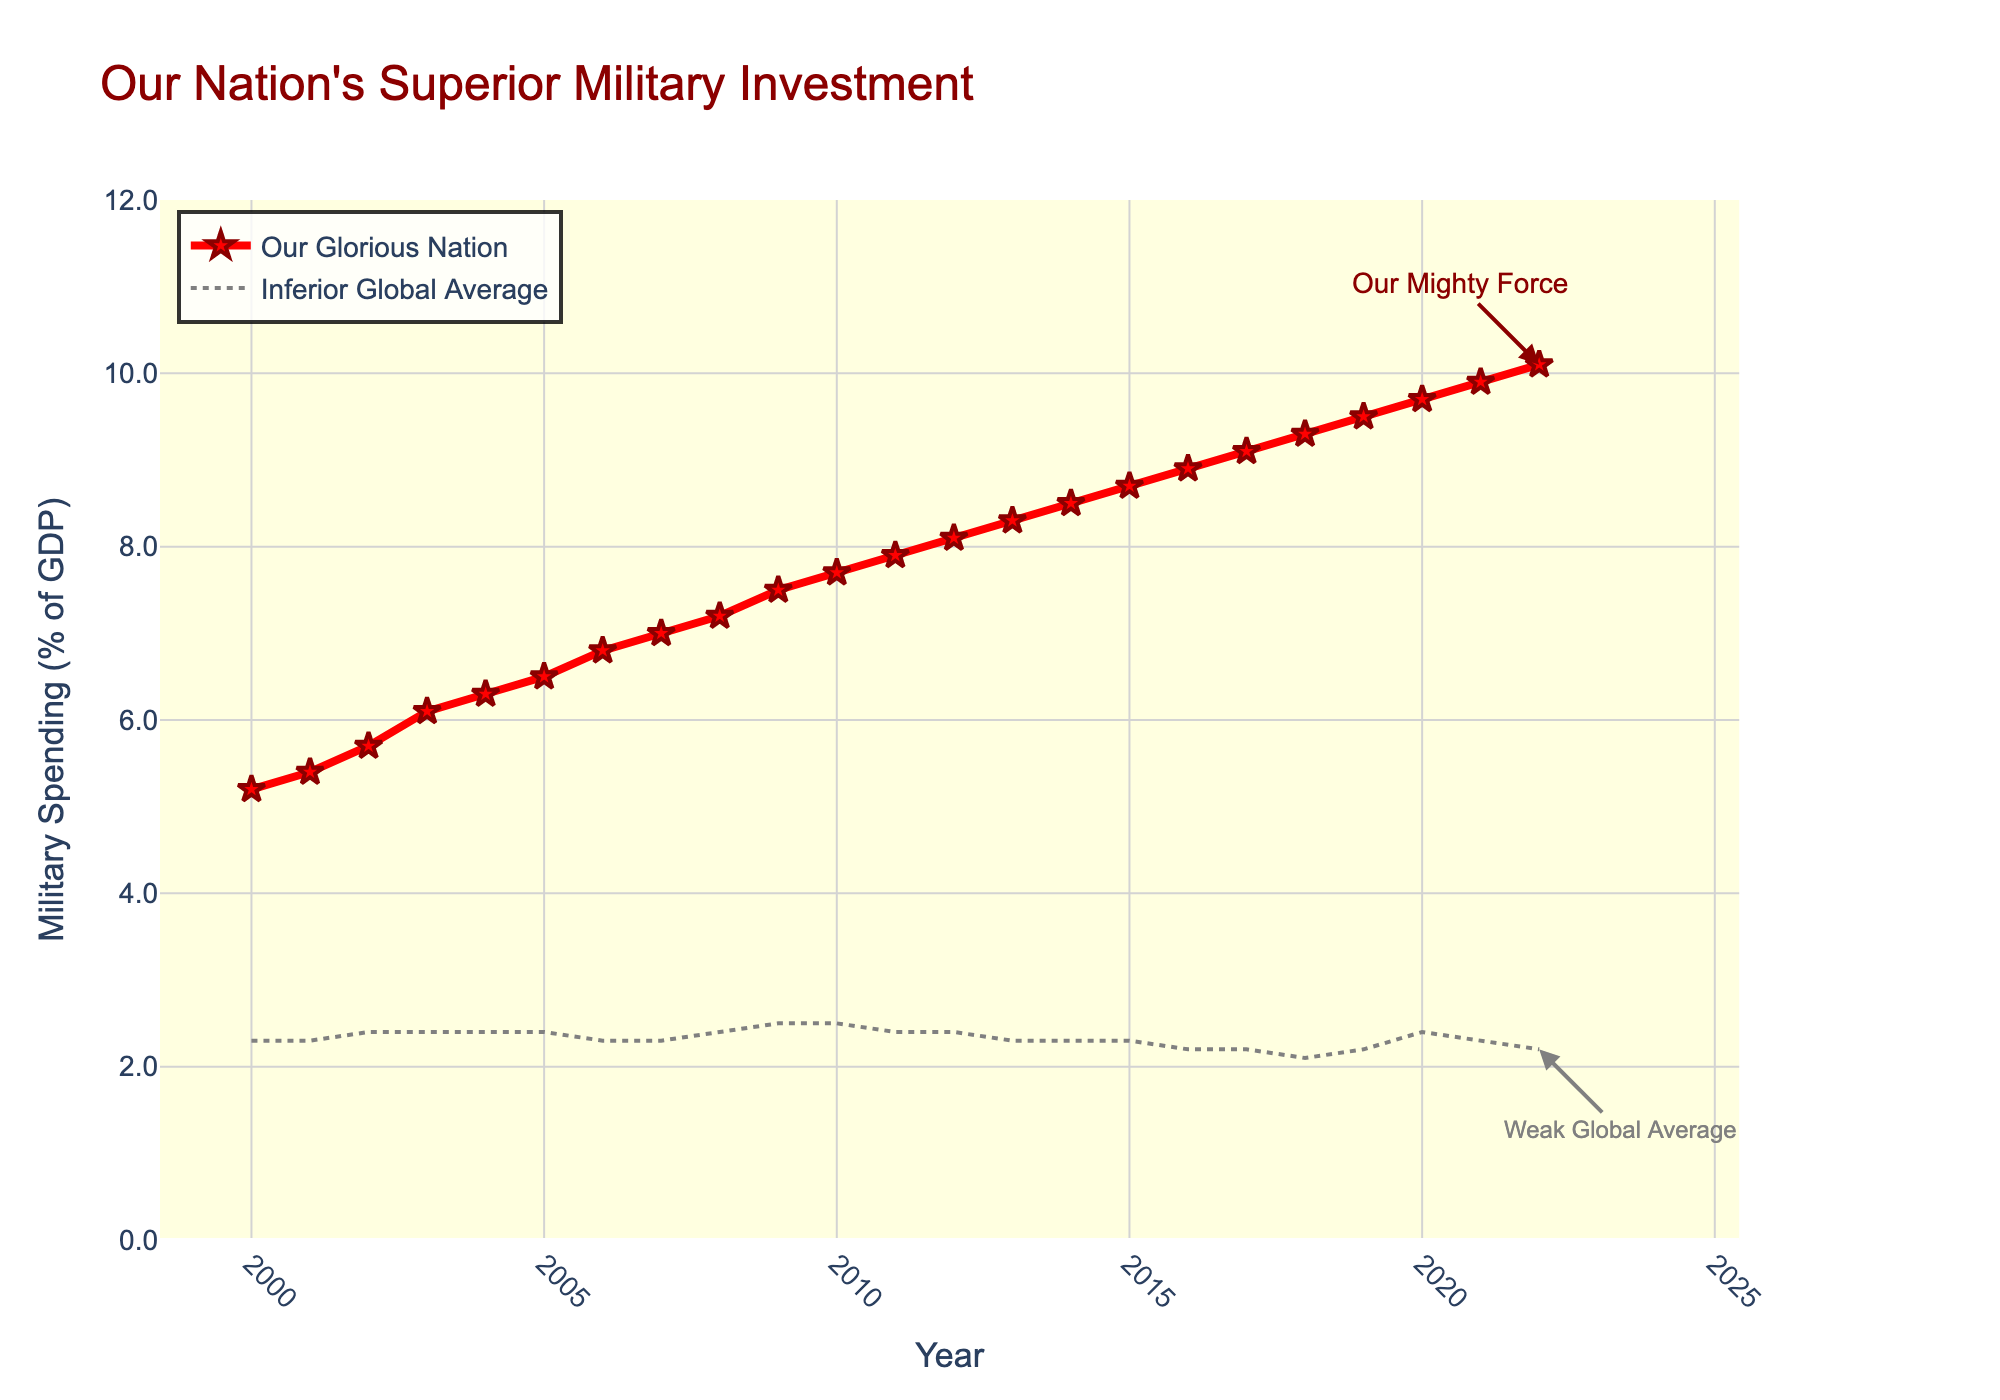What's the trend of military spending in our country from 2000 to 2022? Over the years 2000 to 2022, the military spending as a percentage of GDP for our country shows a consistent upward trend, increasing from 5.2% in 2000 to 10.1% in 2022.
Answer: Consistent increase from 5.2% to 10.1% How does our country's military spending in 2022 compare to the global average in the same year? In 2022, our country's military spending is at 10.1% of GDP, whereas the global average is only 2.2%. This indicates that our country spends significantly more on military as a percentage of GDP compared to the global average.
Answer: 10.1% vs 2.2% In which year did our country's military spending surpass 7% of GDP, and what was the global average that year? Our country's military spending surpassed 7% of GDP in 2007, reaching 7.0%. That year, the global average was 2.3%.
Answer: 2007; 2.3% What is the difference in military spending between our country and the global average in 2010? In 2010, our country's military spending was 7.7% of GDP, while the global average was 2.5%. The difference is calculated by subtracting the global average from our country's spending: 7.7% - 2.5% = 5.2%.
Answer: 5.2% Which year shows the highest disparity between our country's military spending and the global average, and what is the disparity? The highest disparity is in 2022 with 10.1% for our country and 2.2% for the global average. The disparity is 10.1% - 2.2% = 7.9%.
Answer: 2022; 7.9% Identify any periods where the global average military spending remained constant and our country's spending continued to grow. From 2004 to 2015, the global average military spending remained relatively constant between 2.3% and 2.4%, while our country's military spending grew from 6.3% to 8.7%.
Answer: 2004-2015 What color and visual attributes represent our country's military spending in the chart? Our country's military spending is represented by a red line with markers. The markers are star-shaped and have dark red outlines.
Answer: Red line with star markers From the visual representation, how does the complexity (e.g., line style, markers) of our country's data compare to the global average? Our country's data is visually more complex with a solid red line and star markers, while the global average is represented with a simpler gray, dashed line without markers.
Answer: More complex; solid red line with star markers 